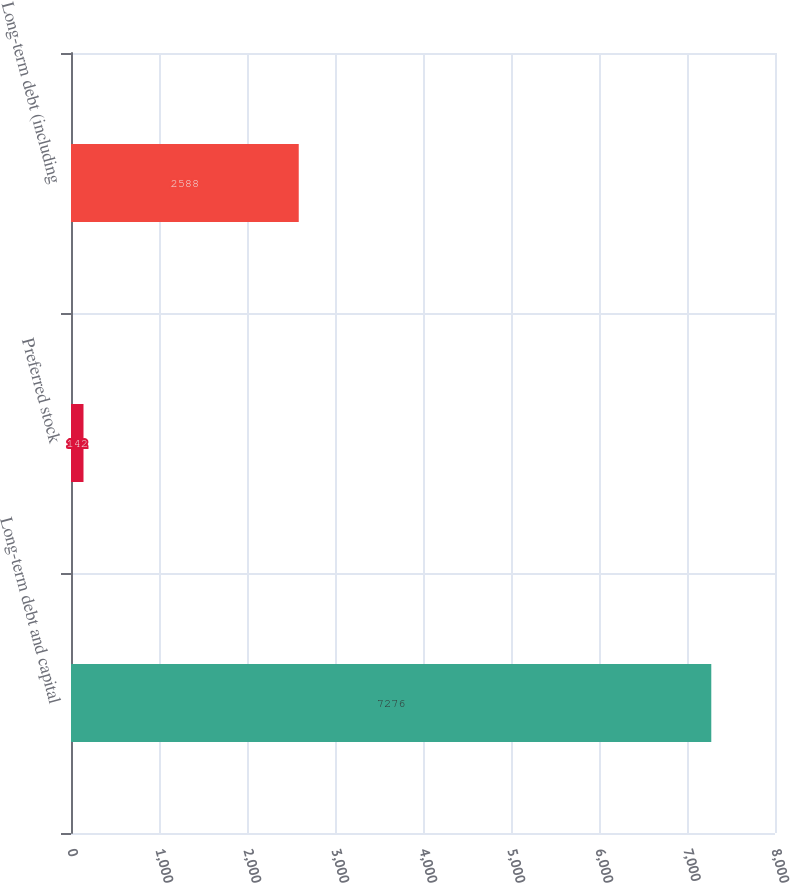<chart> <loc_0><loc_0><loc_500><loc_500><bar_chart><fcel>Long-term debt and capital<fcel>Preferred stock<fcel>Long-term debt (including<nl><fcel>7276<fcel>142<fcel>2588<nl></chart> 